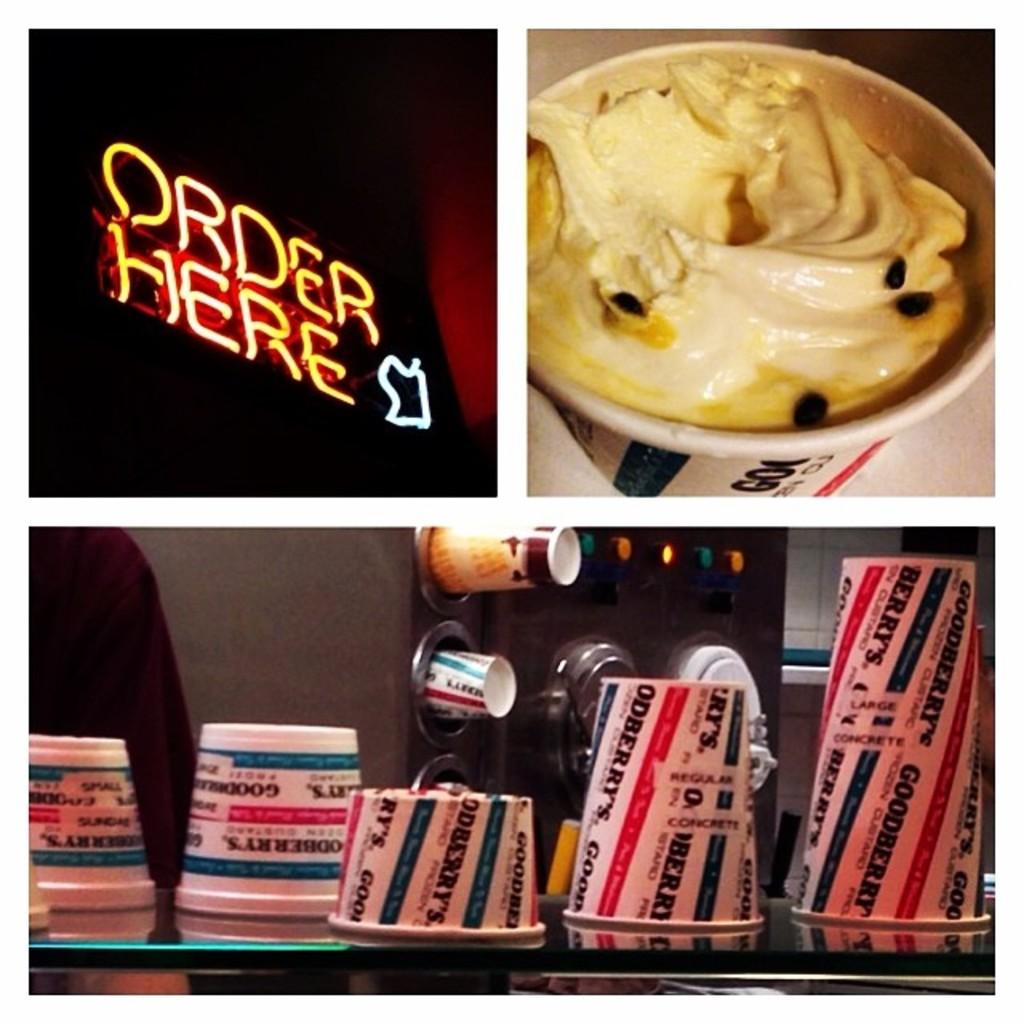Provide a one-sentence caption for the provided image. three different images with one reading order here and oanother with a cup of ice cream. 